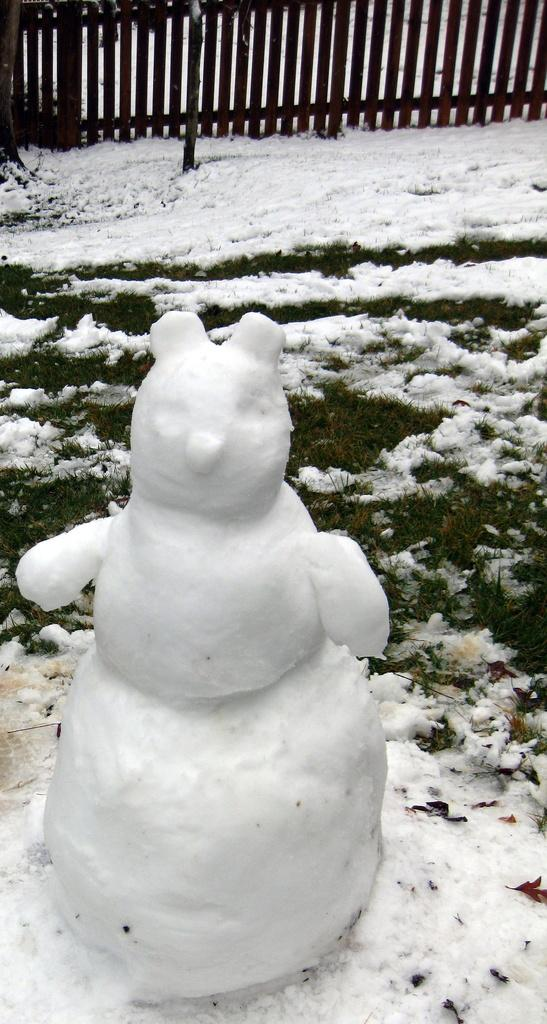What is the main subject of the image? There is a snow doll in the image. What can be seen in the background of the image? The background of the image includes grass covered with snow. What type of structure is visible in the image? There is fencing visible in the image. What type of minister is present in the image? There is no minister present in the image; it features a snow doll and fencing. What type of sheet is covering the snow doll in the image? There is no sheet covering the snow doll in the image; it is made of snow. 